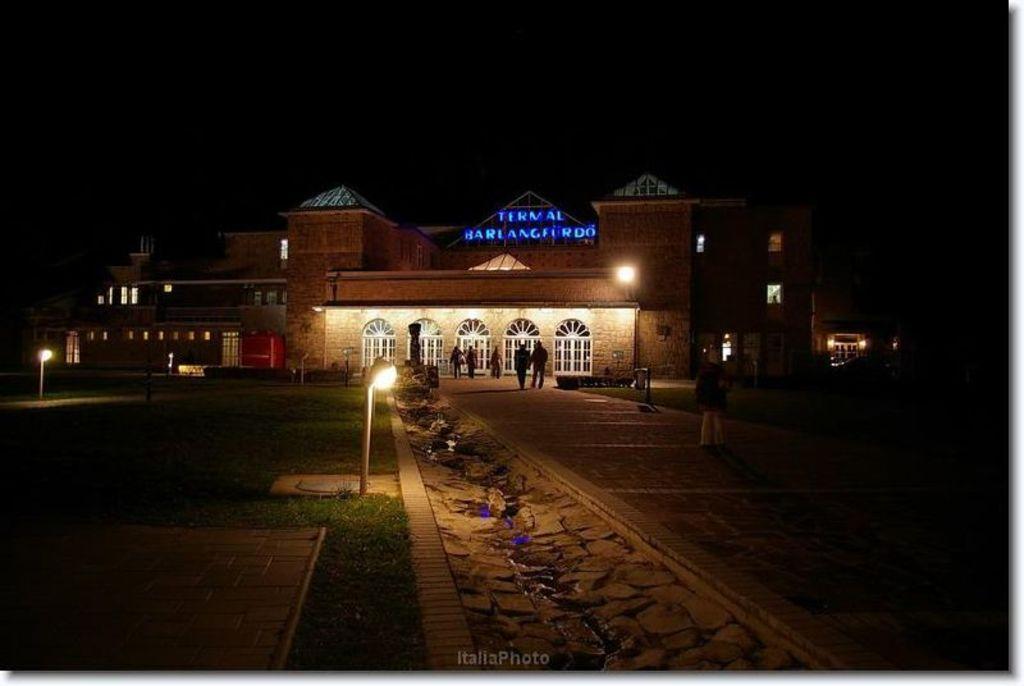Can you describe this image briefly? In the picture we can see a night view of the building with lights to it and some people are walking and standing and we can see two ways near the building filled with grass surface and poles with lights and in the background we can see the sky which is dark. 